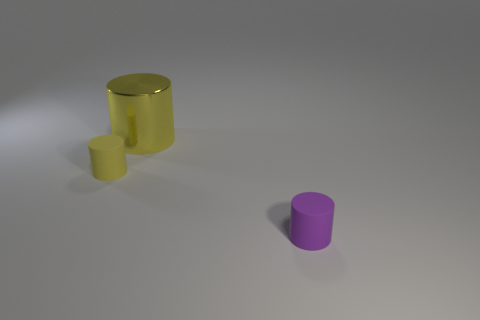Are there any other things that are made of the same material as the large yellow object?
Make the answer very short. No. What number of objects are gray shiny cylinders or small things that are on the left side of the small purple cylinder?
Provide a short and direct response. 1. The cylinder that is the same color as the shiny object is what size?
Offer a terse response. Small. The tiny matte thing on the right side of the big yellow cylinder has what shape?
Offer a terse response. Cylinder. There is a small matte thing on the left side of the large cylinder; is it the same color as the big shiny cylinder?
Make the answer very short. Yes. Is the size of the cylinder that is to the right of the metallic cylinder the same as the tiny yellow thing?
Provide a short and direct response. Yes. Are there any small rubber cylinders of the same color as the large cylinder?
Your response must be concise. Yes. Are there any tiny purple rubber cylinders that are behind the rubber thing to the left of the yellow shiny cylinder?
Make the answer very short. No. Are there any large yellow cylinders made of the same material as the tiny yellow cylinder?
Provide a succinct answer. No. What is the tiny object behind the rubber cylinder that is to the right of the small yellow matte object made of?
Provide a short and direct response. Rubber. 